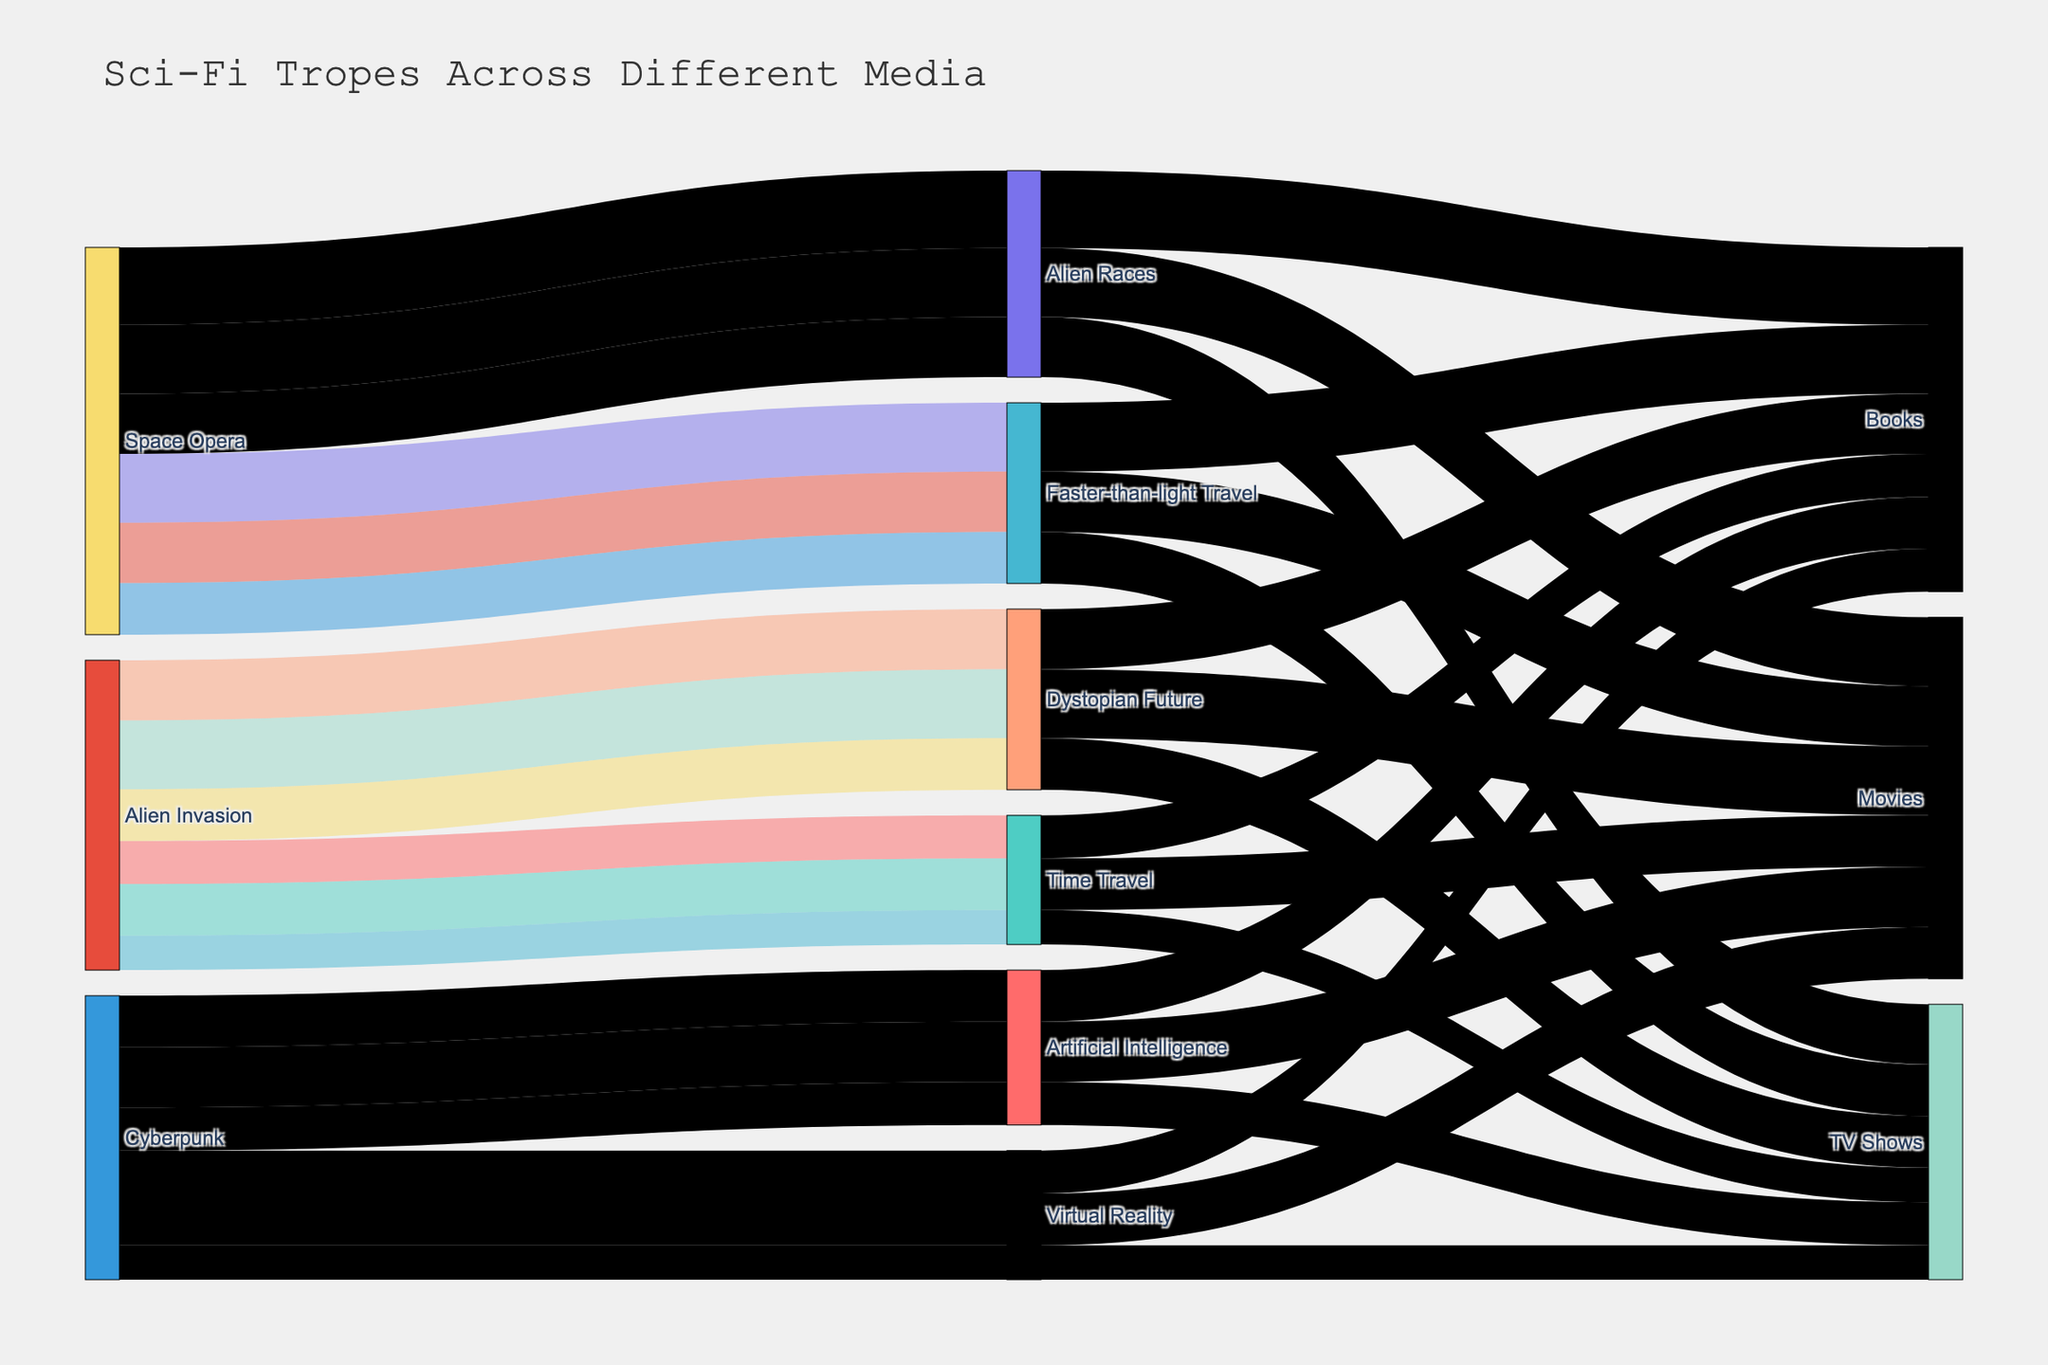What is the title of the figure? The title of the figure is typically displayed at the top and is distinct and larger compared to other text elements. From the code, the title is provided as "Sci-Fi Tropes Across Different Media."
Answer: Sci-Fi Tropes Across Different Media Which Sci-Fi trope in books has the highest prevalence? To answer this, you need to locate the node representing 'Books' and evaluate the links, focusing on the weight associated with each trope. The book with the highest prevalence value is 'Space Opera' since it has both 'Alien Races' (45) and 'Faster-than-light Travel' (40) tropes. 'Alien Races' has the highest value.
Answer: Alien Races How many tropes are associated with the source 'Alien Invasion'? To determine this, identify the 'Alien Invasion' source node and count the number of unique tropes linked to it. According to the data, 'Alien Invasion' is linked to 'Time Travel' and 'Dystopian Future,' which makes two tropes in total.
Answer: 2 Which medium has the highest combined prevalence for 'Cyberpunk' tropes? To find this, sum the prevalence values of 'Cyberpunk' related tropes for each medium. The prevalence sums for 'Books,' 'Movies,' and 'TV Shows' are:
   - Books: 30 (Artificial Intelligence) + 25 (Virtual Reality) = 55
   - Movies: 35 (Artificial Intelligence) + 30 (Virtual Reality) = 65
   - TV Shows: 25 (Artificial Intelligence) + 20 (Virtual Reality) = 45
So, 'Movies' has the highest combined prevalence.
Answer: Movies Which source-trope-medium combination has the lowest prevalence? To answer this, identify the links in the Sankey diagram with the smallest values. From the data, the lowest prevalence is 20 for 'Alien Invasion'→'Time Travel'→'TV Shows' and 'Cyberpunk'→'Virtual Reality'→'TV Shows'. Both have the smallest values in the dataset.
Answer: Alien Invasion to Time Travel in TV Shows OR Cyberpunk to Virtual Reality in TV Shows What is the total prevalence of 'Space Opera' tropes in TV Shows? Add up the prevalence values for 'Space Opera' for the 'TV Shows' medium. The values for 'Faster-than-light Travel' and 'Alien Races' are 30 and 35 respectively. Thus, the total prevalence is 30 + 35 = 65.
Answer: 65 Does 'Cyberpunk' have a higher prevalence in Movies or TV Shows? Compare the total prevalence of 'Cyberpunk' tropes in Movies and TV Shows. The total for Movies is 35 (Artificial Intelligence) + 30 (Virtual Reality) = 65, whereas for TV Shows it is 25 (Artificial Intelligence) + 20 (Virtual Reality) = 45. Thus, 'Cyberpunk' has a higher prevalence in Movies.
Answer: Movies How many unique nodes are present in the Sankey diagram? Count the unique labels for the nodes, which include sources, tropes, and mediums. From the description, we have: 
   - Sources: 3 ('Alien Invasion,' 'Space Opera,' 'Cyberpunk')
   - Tropes: 6 ('Time Travel,' 'Dystopian Future,' 'Faster-than-light Travel,' 'Alien Races,' 'Artificial Intelligence,' 'Virtual Reality')
   - Mediums: 3 ('Books,' 'Movies,' 'TV Shows')
Total unique nodes = 3 + 6 + 3 = 12.
Answer: 12 